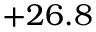<formula> <loc_0><loc_0><loc_500><loc_500>+ 2 6 . 8</formula> 